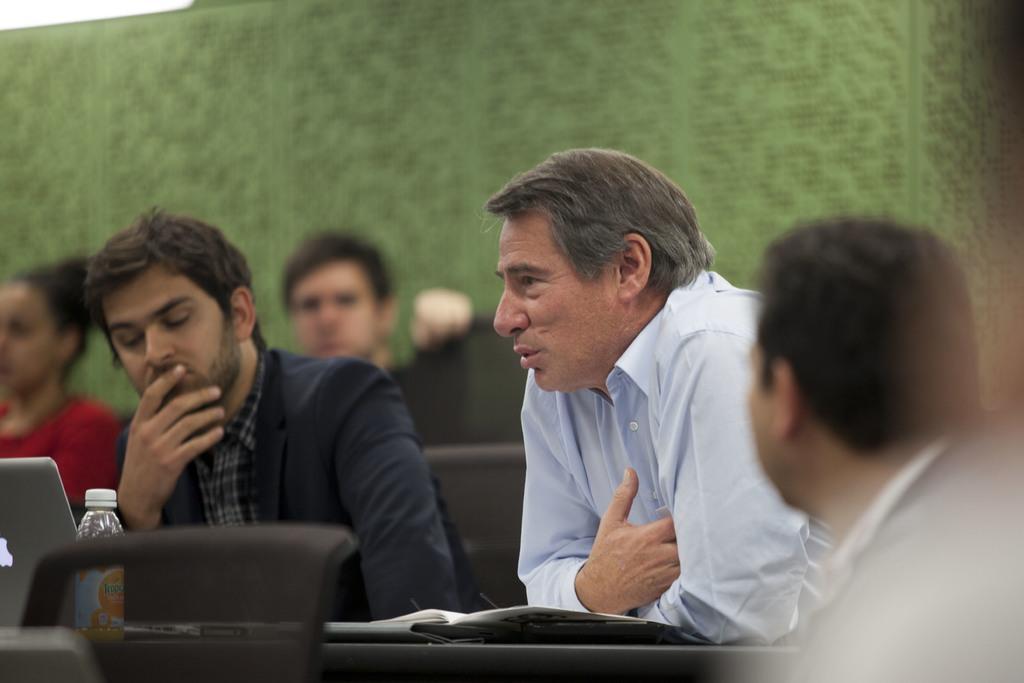Can you describe this image briefly? In the center of the image there are people sitting on chairs. In the background of the image there is a green color carpet. 